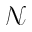<formula> <loc_0><loc_0><loc_500><loc_500>\mathcal { N }</formula> 